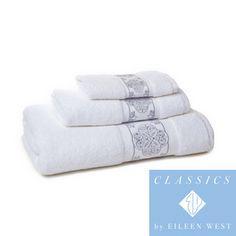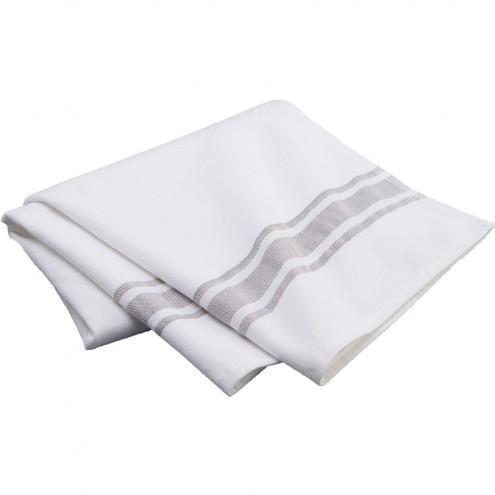The first image is the image on the left, the second image is the image on the right. Evaluate the accuracy of this statement regarding the images: "An image shows a stack of at least two solid gray towels.". Is it true? Answer yes or no. No. 